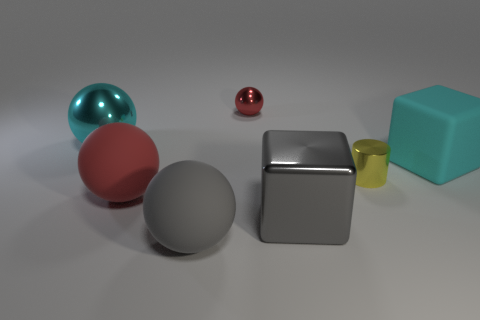The large thing that is the same color as the big metal block is what shape?
Give a very brief answer. Sphere. What number of cylinders have the same size as the yellow object?
Provide a short and direct response. 0. There is a cyan thing in front of the cyan ball; what is its shape?
Provide a short and direct response. Cube. Is the number of large matte spheres less than the number of small cyan balls?
Make the answer very short. No. Is there any other thing of the same color as the cylinder?
Provide a succinct answer. No. How big is the red ball that is in front of the small yellow cylinder?
Your answer should be very brief. Large. Is the number of large green shiny cylinders greater than the number of cyan metallic balls?
Offer a very short reply. No. What material is the tiny red object?
Provide a succinct answer. Metal. How many other things are there of the same material as the tiny yellow thing?
Make the answer very short. 3. How many red balls are there?
Provide a succinct answer. 2. 